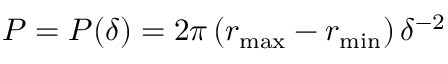Convert formula to latex. <formula><loc_0><loc_0><loc_500><loc_500>P = P ( \delta ) = 2 \pi \left ( r _ { \max } - r _ { \min } \right ) \delta ^ { - 2 }</formula> 